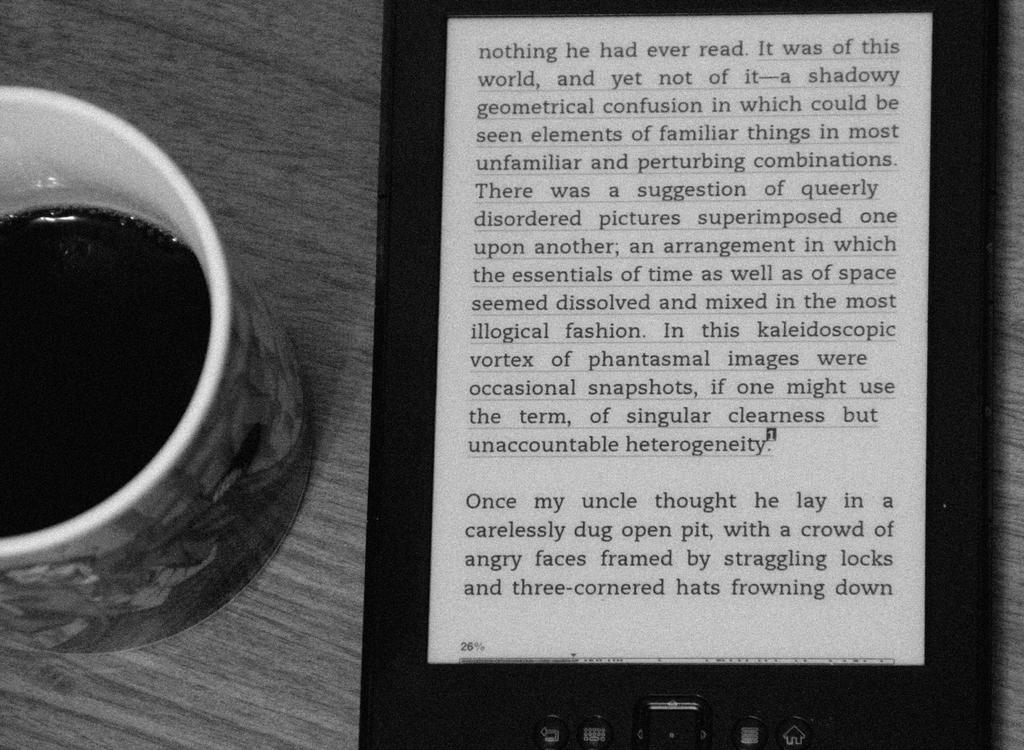<image>
Create a compact narrative representing the image presented. An e-book with a page from a book talking about someone's uncle wearing a three cornered hat. 